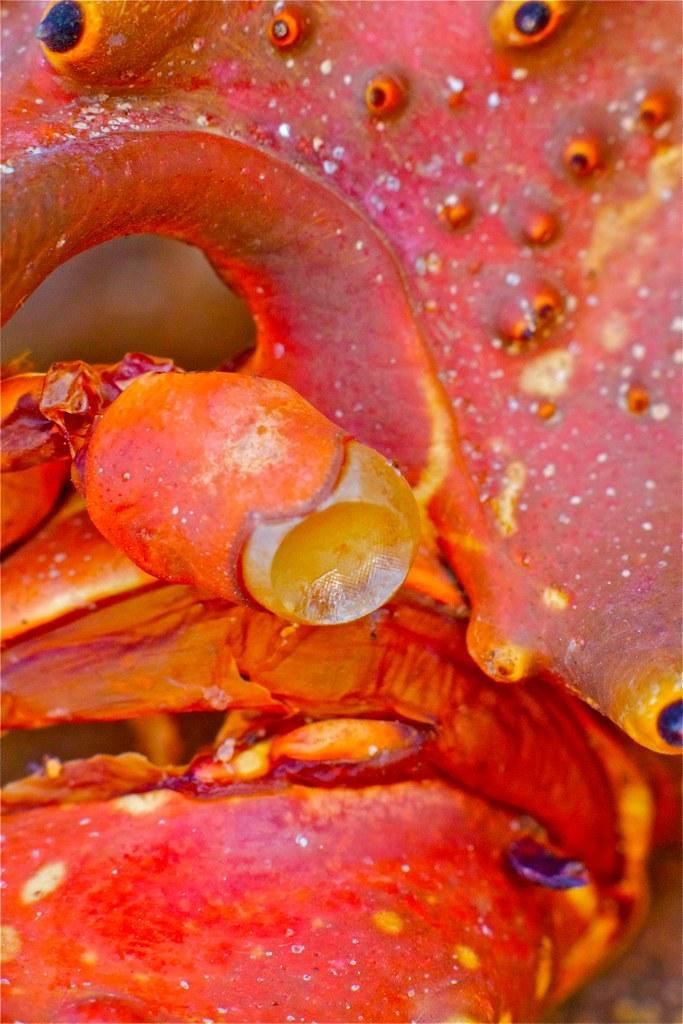What can be seen in the image? There is an object in the image. What colors are present on the object? The object has orange, yellow, and black colors. What is the opinion of the tooth on the cracker in the image? There is no tooth or cracker present in the image, so it is not possible to determine any opinions. 